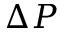<formula> <loc_0><loc_0><loc_500><loc_500>\Delta P</formula> 